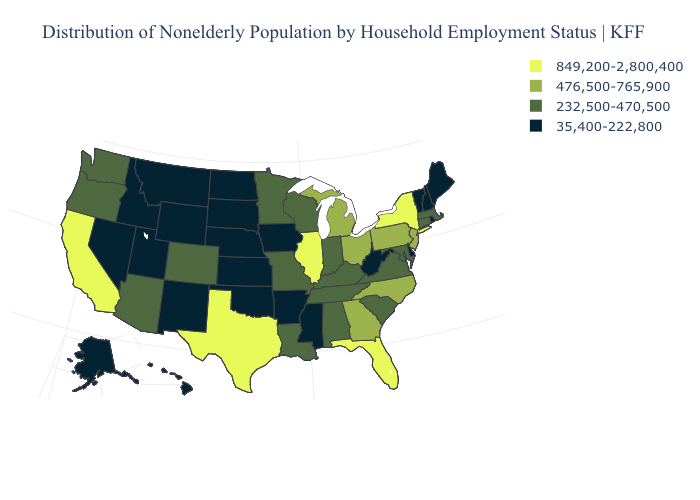Name the states that have a value in the range 232,500-470,500?
Short answer required. Alabama, Arizona, Colorado, Connecticut, Indiana, Kentucky, Louisiana, Maryland, Massachusetts, Minnesota, Missouri, Oregon, South Carolina, Tennessee, Virginia, Washington, Wisconsin. Does the map have missing data?
Give a very brief answer. No. Does Louisiana have the lowest value in the USA?
Quick response, please. No. Among the states that border Iowa , does Nebraska have the lowest value?
Answer briefly. Yes. Name the states that have a value in the range 849,200-2,800,400?
Concise answer only. California, Florida, Illinois, New York, Texas. What is the value of Maryland?
Give a very brief answer. 232,500-470,500. Which states have the lowest value in the USA?
Answer briefly. Alaska, Arkansas, Delaware, Hawaii, Idaho, Iowa, Kansas, Maine, Mississippi, Montana, Nebraska, Nevada, New Hampshire, New Mexico, North Dakota, Oklahoma, Rhode Island, South Dakota, Utah, Vermont, West Virginia, Wyoming. Among the states that border Rhode Island , which have the highest value?
Answer briefly. Connecticut, Massachusetts. What is the value of Oregon?
Keep it brief. 232,500-470,500. Name the states that have a value in the range 476,500-765,900?
Be succinct. Georgia, Michigan, New Jersey, North Carolina, Ohio, Pennsylvania. Does Florida have the same value as Kansas?
Be succinct. No. Does the map have missing data?
Answer briefly. No. What is the highest value in the USA?
Answer briefly. 849,200-2,800,400. What is the lowest value in the MidWest?
Keep it brief. 35,400-222,800. Does the map have missing data?
Answer briefly. No. 